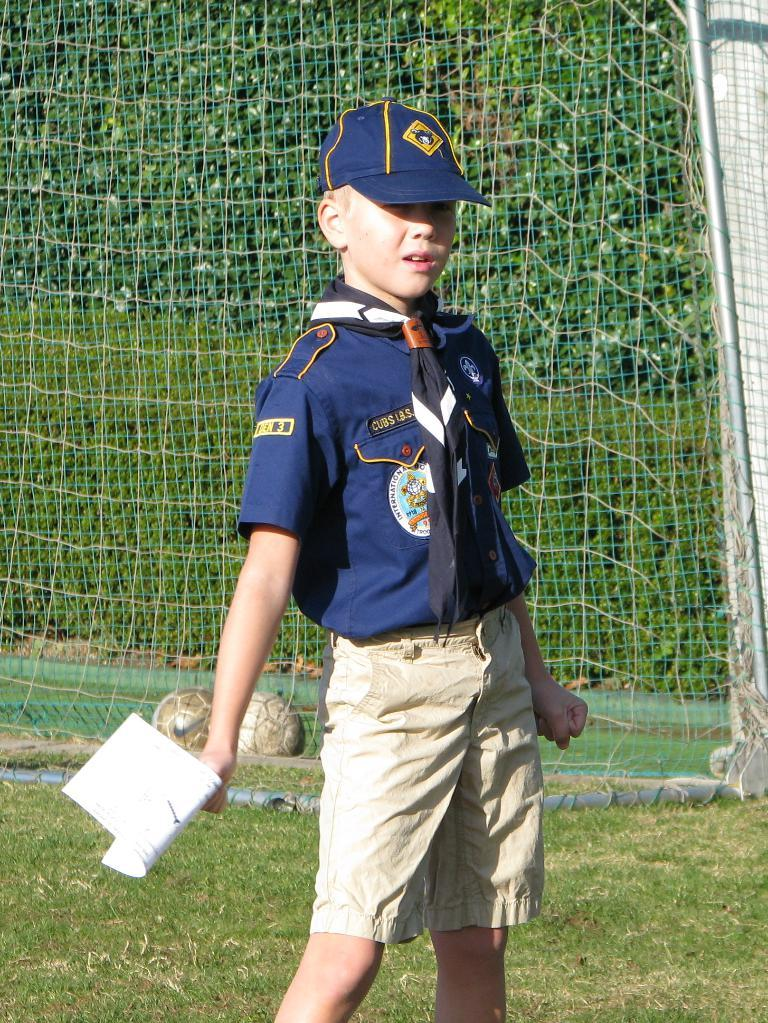What is the person in the image doing? The person is standing in the image. What is the person holding in the image? The person is holding a paper. What is the person wearing in the image? The person is wearing a blue and cream color dress and a blue cap. What can be seen in the background of the image? There are trees and a net visible in the background. What type of thread is being used to hang the shelf in the image? There is no shelf present in the image, so it is not possible to determine what type of thread might be used to hang it. 